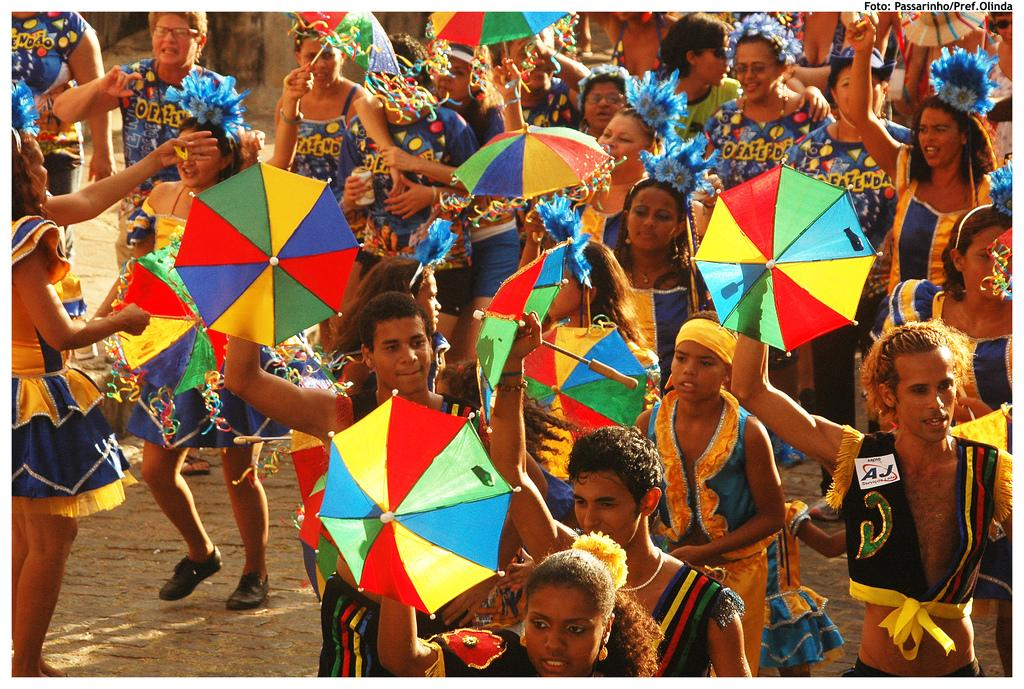Provide a one-sentence caption for the provided image. A group of men and women with rainbow umbrellas, one with a name tag AJ. 